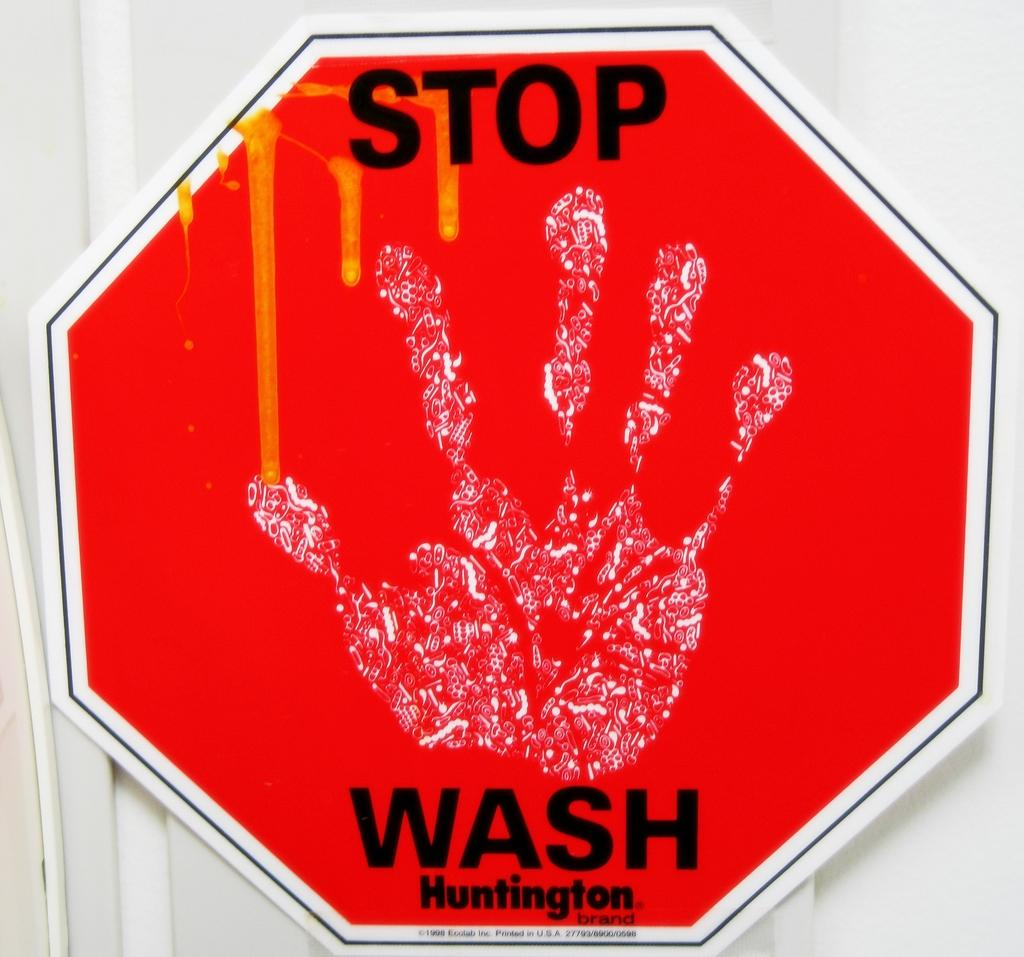<image>
Present a compact description of the photo's key features. The big red sign reads Stop Wash Huntington 